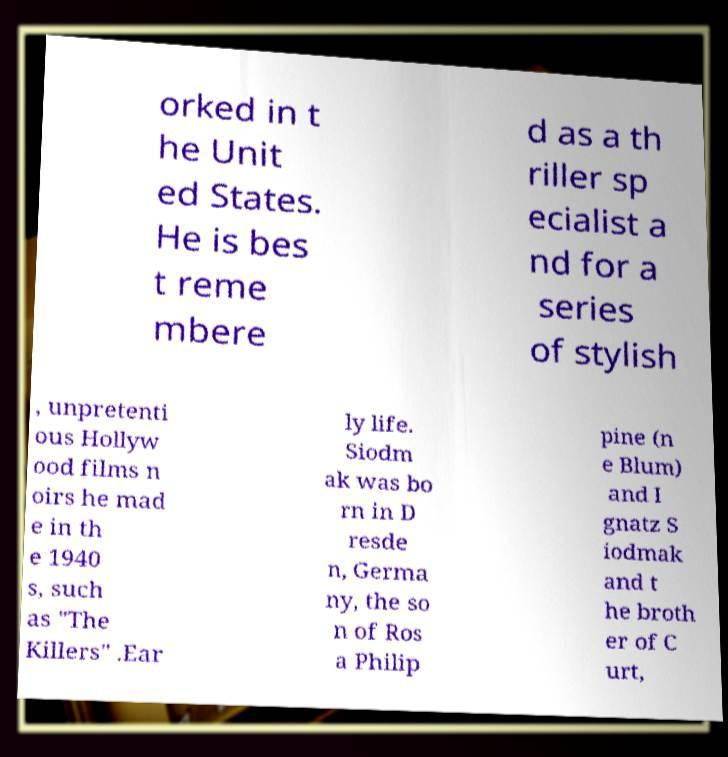Please read and relay the text visible in this image. What does it say? orked in t he Unit ed States. He is bes t reme mbere d as a th riller sp ecialist a nd for a series of stylish , unpretenti ous Hollyw ood films n oirs he mad e in th e 1940 s, such as "The Killers" .Ear ly life. Siodm ak was bo rn in D resde n, Germa ny, the so n of Ros a Philip pine (n e Blum) and I gnatz S iodmak and t he broth er of C urt, 